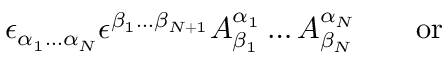Convert formula to latex. <formula><loc_0><loc_0><loc_500><loc_500>\epsilon _ { \alpha _ { 1 } \dots \alpha _ { N } } \epsilon ^ { \beta _ { 1 } \dots \beta _ { N + 1 } } A _ { \beta _ { 1 } } ^ { \alpha _ { 1 } } \dots A _ { \beta _ { N } } ^ { \alpha _ { N } } \quad o r</formula> 